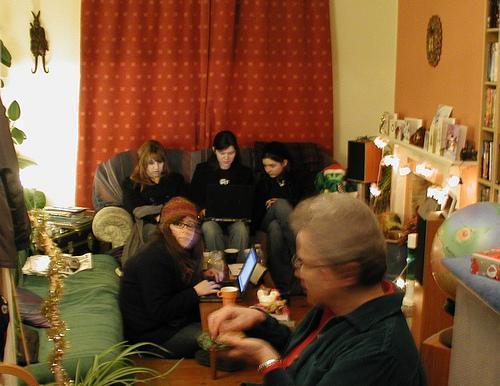How many people are in this photo?
Give a very brief answer. 5. How many people are in the picture?
Give a very brief answer. 5. How many couches are in the picture?
Give a very brief answer. 2. How many black umbrellas are in the image?
Give a very brief answer. 0. 